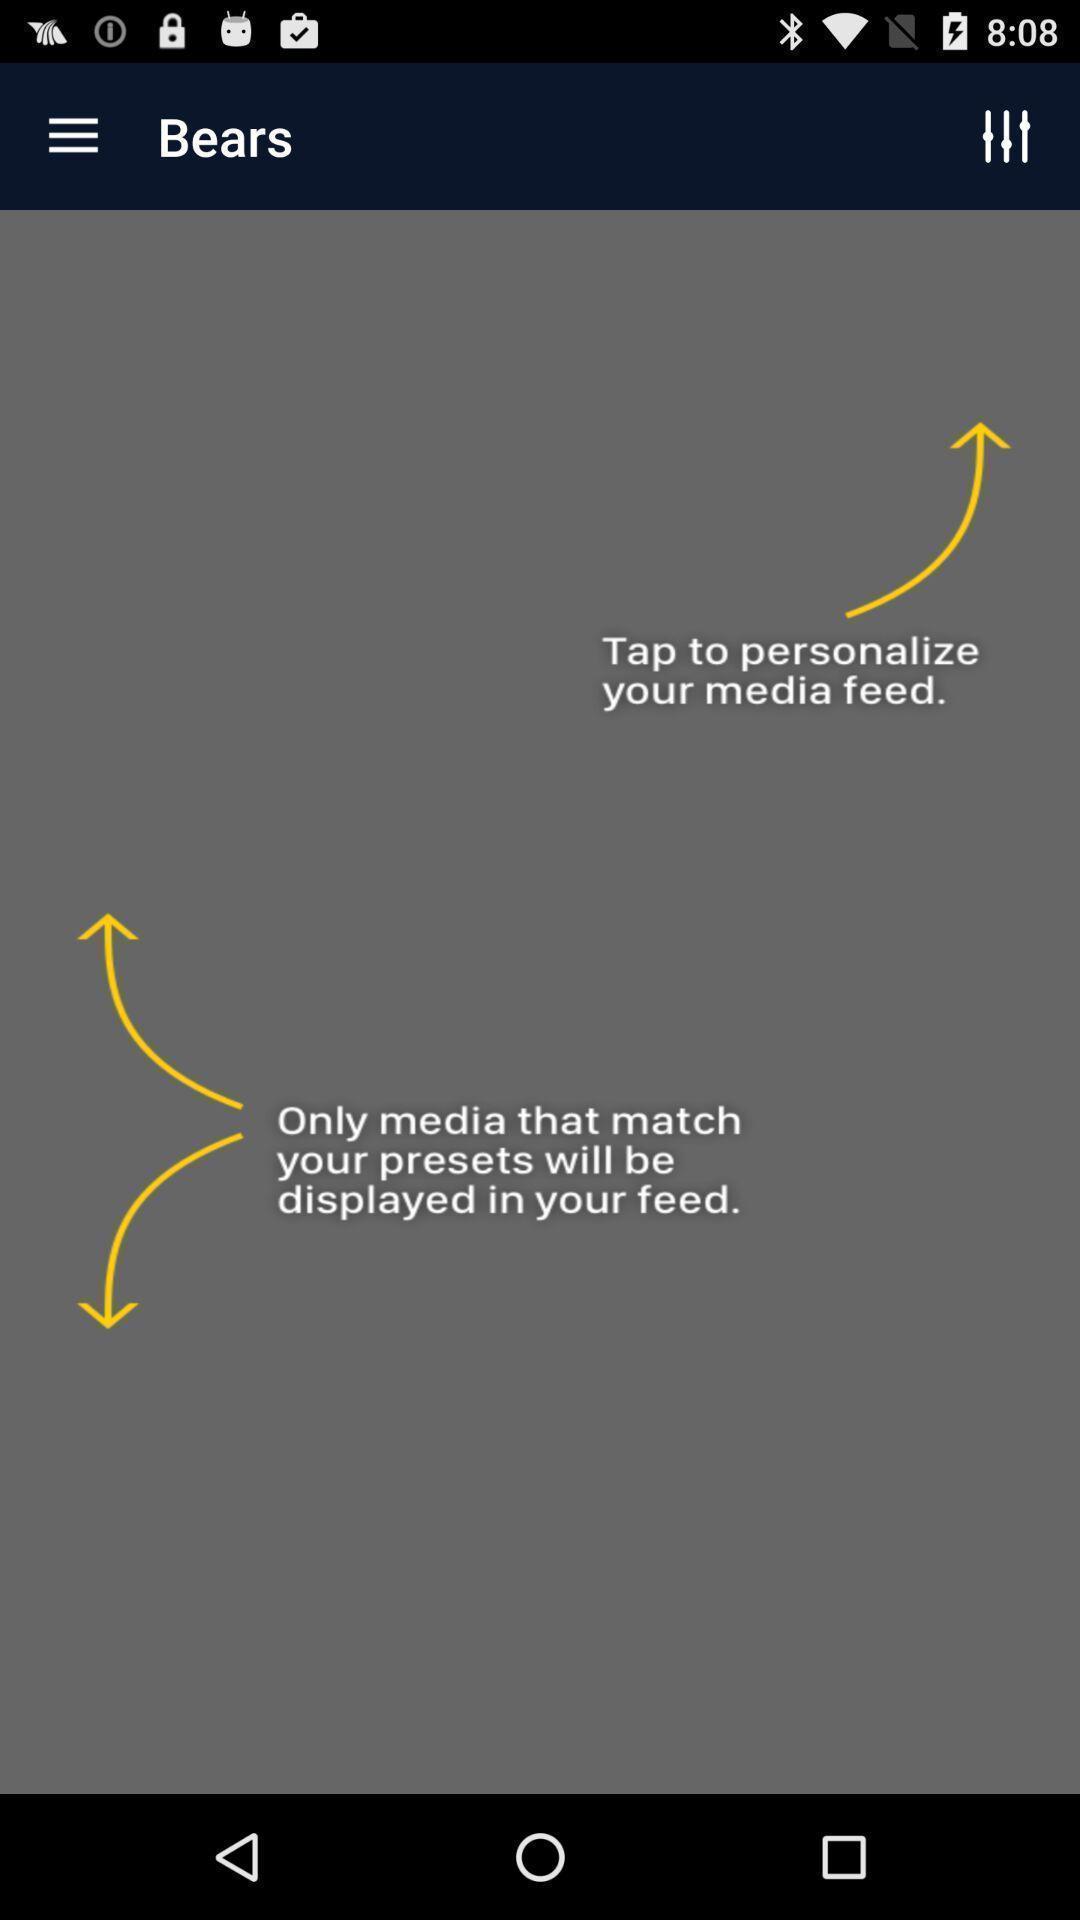Provide a detailed account of this screenshot. Pop-up shows instructions. 